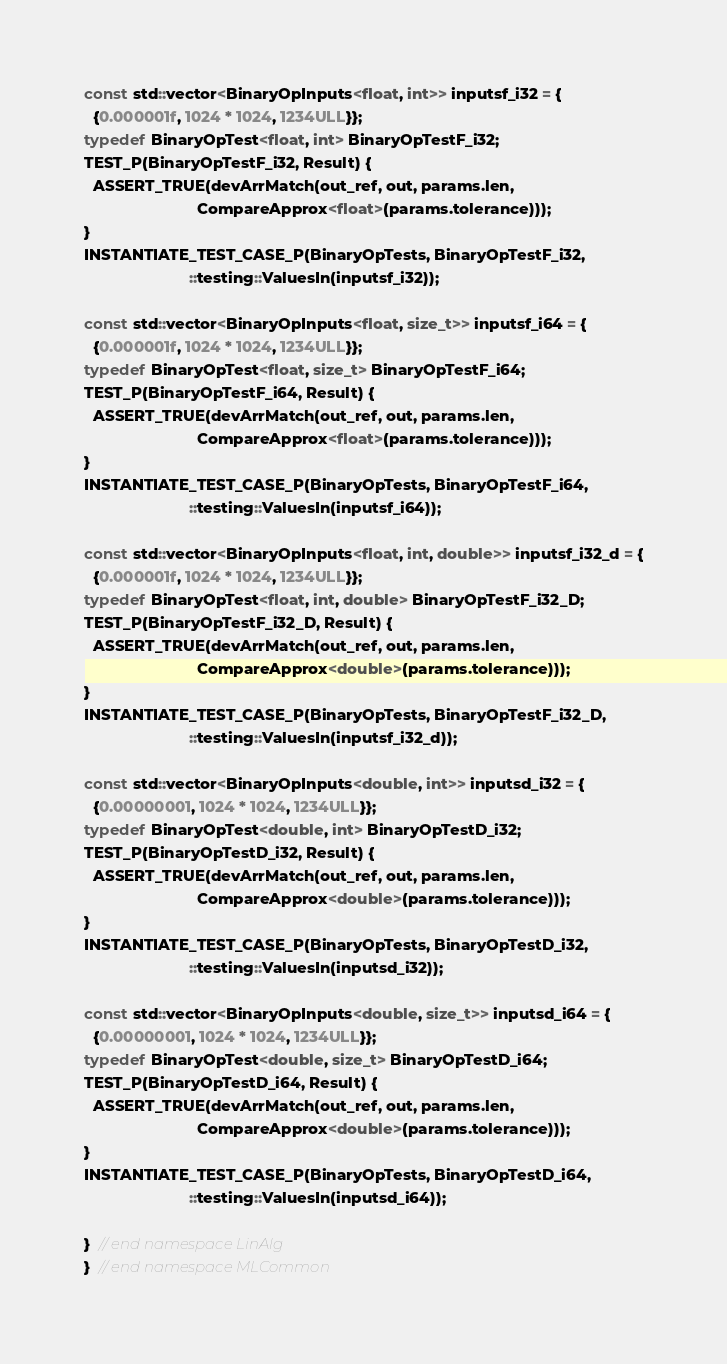<code> <loc_0><loc_0><loc_500><loc_500><_Cuda_>
const std::vector<BinaryOpInputs<float, int>> inputsf_i32 = {
  {0.000001f, 1024 * 1024, 1234ULL}};
typedef BinaryOpTest<float, int> BinaryOpTestF_i32;
TEST_P(BinaryOpTestF_i32, Result) {
  ASSERT_TRUE(devArrMatch(out_ref, out, params.len,
                          CompareApprox<float>(params.tolerance)));
}
INSTANTIATE_TEST_CASE_P(BinaryOpTests, BinaryOpTestF_i32,
                        ::testing::ValuesIn(inputsf_i32));

const std::vector<BinaryOpInputs<float, size_t>> inputsf_i64 = {
  {0.000001f, 1024 * 1024, 1234ULL}};
typedef BinaryOpTest<float, size_t> BinaryOpTestF_i64;
TEST_P(BinaryOpTestF_i64, Result) {
  ASSERT_TRUE(devArrMatch(out_ref, out, params.len,
                          CompareApprox<float>(params.tolerance)));
}
INSTANTIATE_TEST_CASE_P(BinaryOpTests, BinaryOpTestF_i64,
                        ::testing::ValuesIn(inputsf_i64));

const std::vector<BinaryOpInputs<float, int, double>> inputsf_i32_d = {
  {0.000001f, 1024 * 1024, 1234ULL}};
typedef BinaryOpTest<float, int, double> BinaryOpTestF_i32_D;
TEST_P(BinaryOpTestF_i32_D, Result) {
  ASSERT_TRUE(devArrMatch(out_ref, out, params.len,
                          CompareApprox<double>(params.tolerance)));
}
INSTANTIATE_TEST_CASE_P(BinaryOpTests, BinaryOpTestF_i32_D,
                        ::testing::ValuesIn(inputsf_i32_d));

const std::vector<BinaryOpInputs<double, int>> inputsd_i32 = {
  {0.00000001, 1024 * 1024, 1234ULL}};
typedef BinaryOpTest<double, int> BinaryOpTestD_i32;
TEST_P(BinaryOpTestD_i32, Result) {
  ASSERT_TRUE(devArrMatch(out_ref, out, params.len,
                          CompareApprox<double>(params.tolerance)));
}
INSTANTIATE_TEST_CASE_P(BinaryOpTests, BinaryOpTestD_i32,
                        ::testing::ValuesIn(inputsd_i32));

const std::vector<BinaryOpInputs<double, size_t>> inputsd_i64 = {
  {0.00000001, 1024 * 1024, 1234ULL}};
typedef BinaryOpTest<double, size_t> BinaryOpTestD_i64;
TEST_P(BinaryOpTestD_i64, Result) {
  ASSERT_TRUE(devArrMatch(out_ref, out, params.len,
                          CompareApprox<double>(params.tolerance)));
}
INSTANTIATE_TEST_CASE_P(BinaryOpTests, BinaryOpTestD_i64,
                        ::testing::ValuesIn(inputsd_i64));

}  // end namespace LinAlg
}  // end namespace MLCommon
</code> 